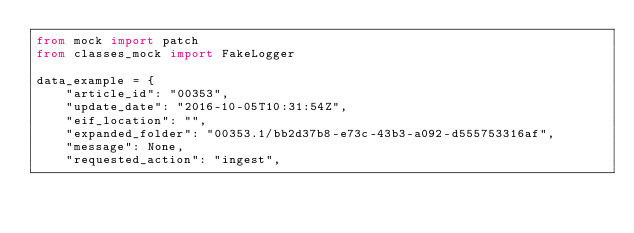<code> <loc_0><loc_0><loc_500><loc_500><_Python_>from mock import patch
from classes_mock import FakeLogger

data_example = {
    "article_id": "00353",
    "update_date": "2016-10-05T10:31:54Z",
    "eif_location": "",
    "expanded_folder": "00353.1/bb2d37b8-e73c-43b3-a092-d555753316af",
    "message": None,
    "requested_action": "ingest",</code> 